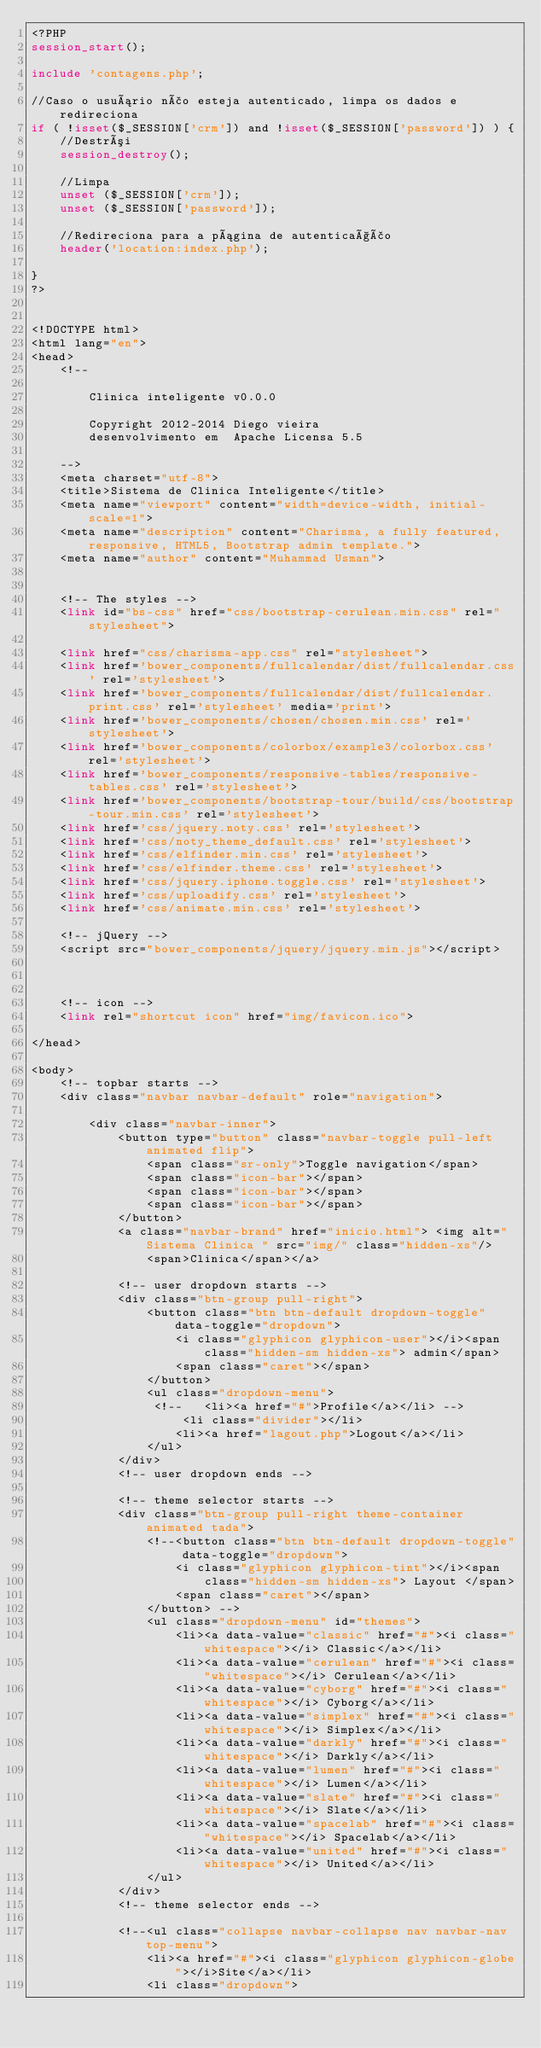Convert code to text. <code><loc_0><loc_0><loc_500><loc_500><_PHP_><?PHP
session_start();
 
include 'contagens.php'; 

//Caso o usuário não esteja autenticado, limpa os dados e redireciona
if ( !isset($_SESSION['crm']) and !isset($_SESSION['password']) ) {
    //Destrói
    session_destroy();
 
    //Limpa
    unset ($_SESSION['crm']);
    unset ($_SESSION['password']);
     
    //Redireciona para a página de autenticação
    header('location:index.php');
	
}
?>


<!DOCTYPE html>
<html lang="en">
<head>
    <!--
  
        Clinica inteligente v0.0.0

        Copyright 2012-2014 Diego vieira
        desenvolvimento em  Apache Licensa 5.5
 
    -->
    <meta charset="utf-8">
    <title>Sistema de Clinica Inteligente</title>
    <meta name="viewport" content="width=device-width, initial-scale=1">
    <meta name="description" content="Charisma, a fully featured, responsive, HTML5, Bootstrap admin template.">
    <meta name="author" content="Muhammad Usman">
    

    <!-- The styles -->
    <link id="bs-css" href="css/bootstrap-cerulean.min.css" rel="stylesheet">

    <link href="css/charisma-app.css" rel="stylesheet">
    <link href='bower_components/fullcalendar/dist/fullcalendar.css' rel='stylesheet'>
    <link href='bower_components/fullcalendar/dist/fullcalendar.print.css' rel='stylesheet' media='print'>
    <link href='bower_components/chosen/chosen.min.css' rel='stylesheet'>
    <link href='bower_components/colorbox/example3/colorbox.css' rel='stylesheet'>
    <link href='bower_components/responsive-tables/responsive-tables.css' rel='stylesheet'>
    <link href='bower_components/bootstrap-tour/build/css/bootstrap-tour.min.css' rel='stylesheet'>
    <link href='css/jquery.noty.css' rel='stylesheet'>
    <link href='css/noty_theme_default.css' rel='stylesheet'>
    <link href='css/elfinder.min.css' rel='stylesheet'>
    <link href='css/elfinder.theme.css' rel='stylesheet'>
    <link href='css/jquery.iphone.toggle.css' rel='stylesheet'>
    <link href='css/uploadify.css' rel='stylesheet'>
    <link href='css/animate.min.css' rel='stylesheet'>

    <!-- jQuery -->
    <script src="bower_components/jquery/jquery.min.js"></script>

  

    <!-- icon -->
    <link rel="shortcut icon" href="img/favicon.ico">

</head>

<body>
    <!-- topbar starts -->
    <div class="navbar navbar-default" role="navigation">

        <div class="navbar-inner">
            <button type="button" class="navbar-toggle pull-left animated flip">
                <span class="sr-only">Toggle navigation</span>
                <span class="icon-bar"></span>
                <span class="icon-bar"></span>
                <span class="icon-bar"></span>
            </button>
            <a class="navbar-brand" href="inicio.html"> <img alt="Sistema Clinica " src="img/" class="hidden-xs"/>
                <span>Clinica</span></a>

            <!-- user dropdown starts -->
            <div class="btn-group pull-right">
                <button class="btn btn-default dropdown-toggle" data-toggle="dropdown">
                    <i class="glyphicon glyphicon-user"></i><span class="hidden-sm hidden-xs"> admin</span>
                    <span class="caret"></span>
                </button>
                <ul class="dropdown-menu">
                 <!--   <li><a href="#">Profile</a></li> -->
                     <li class="divider"></li>
                    <li><a href="lagout.php">Logout</a></li>
                </ul>
            </div>
            <!-- user dropdown ends -->

            <!-- theme selector starts -->
            <div class="btn-group pull-right theme-container animated tada">
                <!--<button class="btn btn-default dropdown-toggle" data-toggle="dropdown">
                    <i class="glyphicon glyphicon-tint"></i><span
                        class="hidden-sm hidden-xs"> Layout </span>
                    <span class="caret"></span>
                </button> -->
                <ul class="dropdown-menu" id="themes">
                    <li><a data-value="classic" href="#"><i class="whitespace"></i> Classic</a></li>
                    <li><a data-value="cerulean" href="#"><i class="whitespace"></i> Cerulean</a></li>
                    <li><a data-value="cyborg" href="#"><i class="whitespace"></i> Cyborg</a></li>
                    <li><a data-value="simplex" href="#"><i class="whitespace"></i> Simplex</a></li>
                    <li><a data-value="darkly" href="#"><i class="whitespace"></i> Darkly</a></li>
                    <li><a data-value="lumen" href="#"><i class="whitespace"></i> Lumen</a></li>
                    <li><a data-value="slate" href="#"><i class="whitespace"></i> Slate</a></li>
                    <li><a data-value="spacelab" href="#"><i class="whitespace"></i> Spacelab</a></li>
                    <li><a data-value="united" href="#"><i class="whitespace"></i> United</a></li>
                </ul>
            </div>
            <!-- theme selector ends -->

            <!--<ul class="collapse navbar-collapse nav navbar-nav top-menu">
                <li><a href="#"><i class="glyphicon glyphicon-globe"></i>Site</a></li>
                <li class="dropdown"></code> 